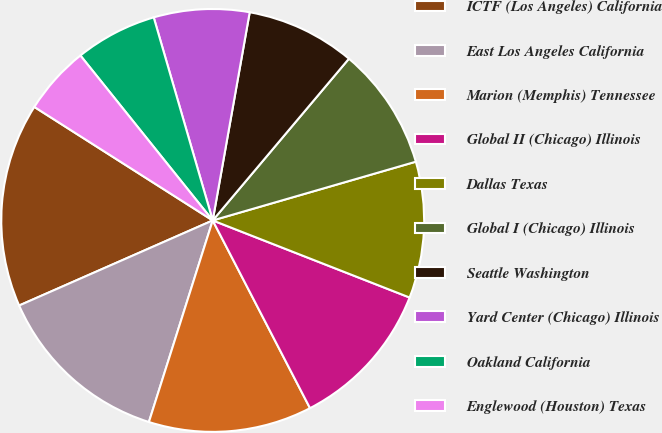<chart> <loc_0><loc_0><loc_500><loc_500><pie_chart><fcel>ICTF (Los Angeles) California<fcel>East Los Angeles California<fcel>Marion (Memphis) Tennessee<fcel>Global II (Chicago) Illinois<fcel>Dallas Texas<fcel>Global I (Chicago) Illinois<fcel>Seattle Washington<fcel>Yard Center (Chicago) Illinois<fcel>Oakland California<fcel>Englewood (Houston) Texas<nl><fcel>15.61%<fcel>13.53%<fcel>12.49%<fcel>11.45%<fcel>10.42%<fcel>9.38%<fcel>8.34%<fcel>7.3%<fcel>6.26%<fcel>5.22%<nl></chart> 